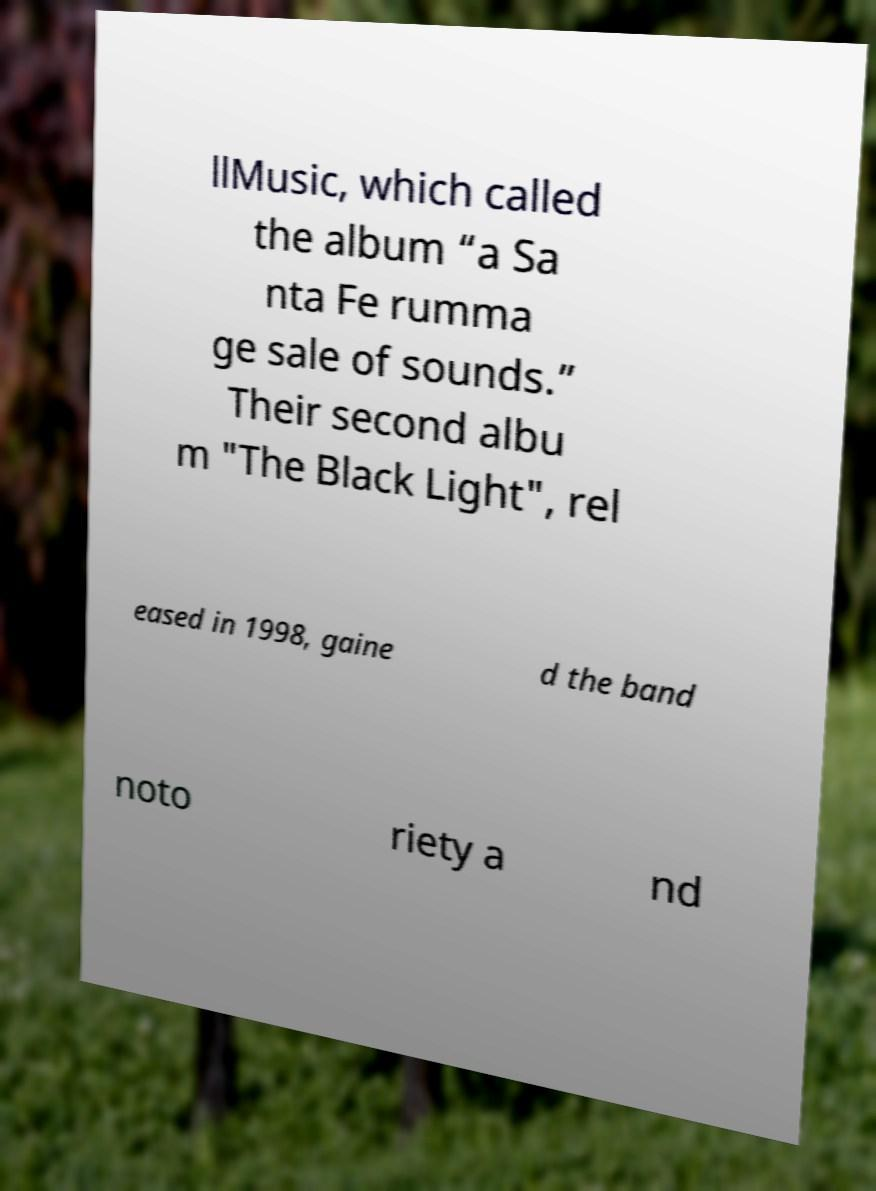For documentation purposes, I need the text within this image transcribed. Could you provide that? llMusic, which called the album “a Sa nta Fe rumma ge sale of sounds.” Their second albu m "The Black Light", rel eased in 1998, gaine d the band noto riety a nd 